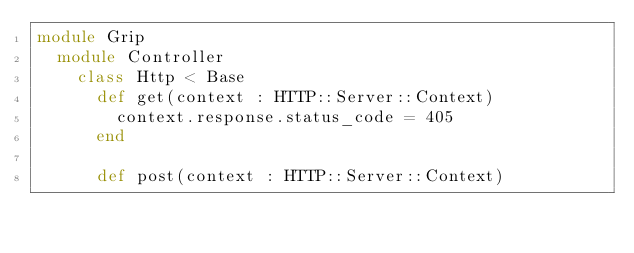Convert code to text. <code><loc_0><loc_0><loc_500><loc_500><_Crystal_>module Grip
  module Controller
    class Http < Base
      def get(context : HTTP::Server::Context)
        context.response.status_code = 405
      end

      def post(context : HTTP::Server::Context)</code> 